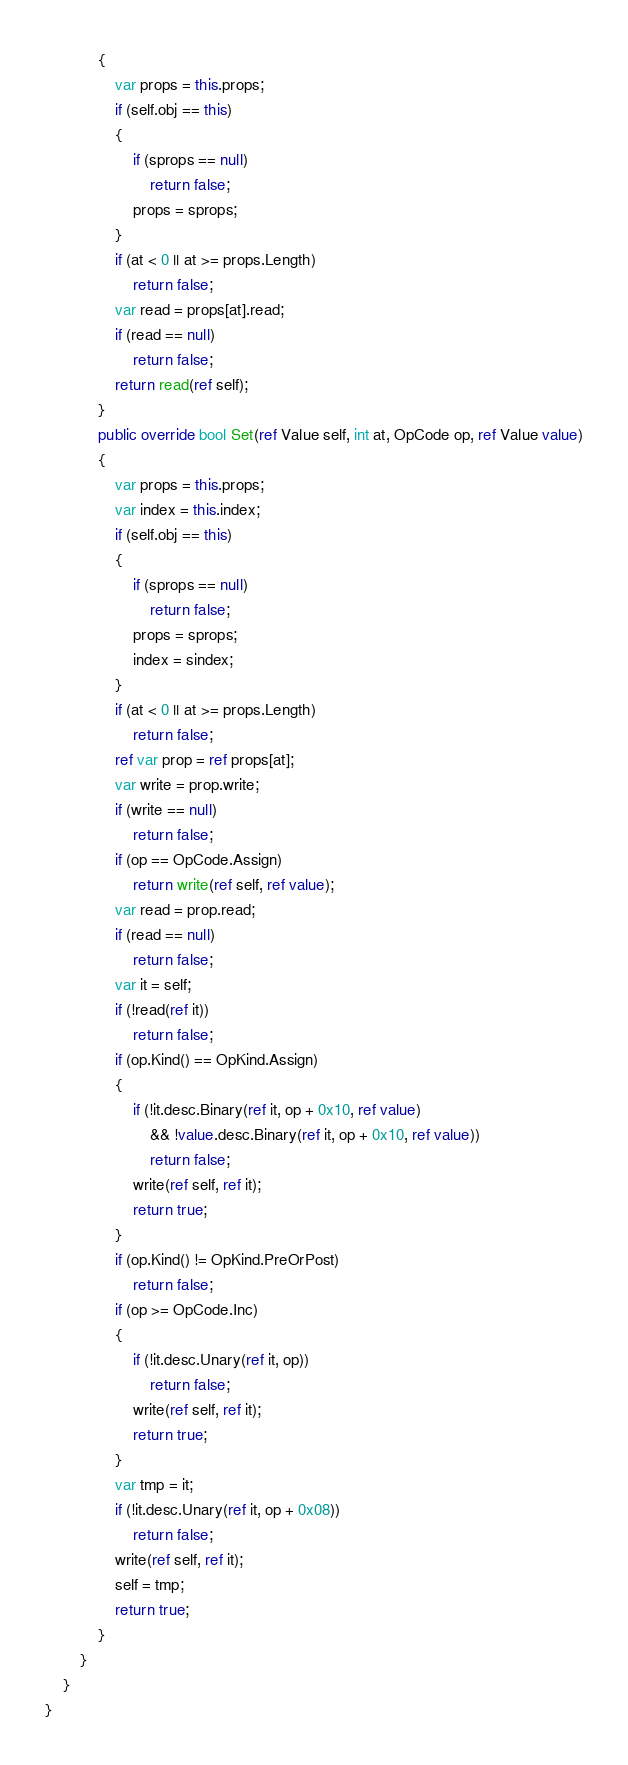<code> <loc_0><loc_0><loc_500><loc_500><_C#_>			{
				var props = this.props;
				if (self.obj == this)
				{
					if (sprops == null)
						return false;
					props = sprops;
				}
				if (at < 0 || at >= props.Length)
					return false;
				var read = props[at].read;
				if (read == null)
					return false;
				return read(ref self);
			}
			public override bool Set(ref Value self, int at, OpCode op, ref Value value)
			{
				var props = this.props;
				var index = this.index;
				if (self.obj == this)
				{
					if (sprops == null)
						return false;
					props = sprops;
					index = sindex;
				}
				if (at < 0 || at >= props.Length)
					return false;
				ref var prop = ref props[at];
				var write = prop.write;
				if (write == null)
					return false;
				if (op == OpCode.Assign)
					return write(ref self, ref value);
				var read = prop.read;
				if (read == null)
					return false;
				var it = self;
				if (!read(ref it))
					return false;
				if (op.Kind() == OpKind.Assign)
				{
					if (!it.desc.Binary(ref it, op + 0x10, ref value)
						&& !value.desc.Binary(ref it, op + 0x10, ref value))
						return false;
					write(ref self, ref it);
					return true;
				}
				if (op.Kind() != OpKind.PreOrPost)
					return false;
				if (op >= OpCode.Inc)
				{
					if (!it.desc.Unary(ref it, op))
						return false;
					write(ref self, ref it);
					return true;
				}
				var tmp = it;
				if (!it.desc.Unary(ref it, op + 0x08))
					return false;
				write(ref self, ref it);
				self = tmp;
				return true;
			}
		}
	}
}
</code> 